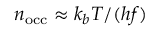<formula> <loc_0><loc_0><loc_500><loc_500>n _ { o c c } \approx k _ { b } T / ( h f )</formula> 